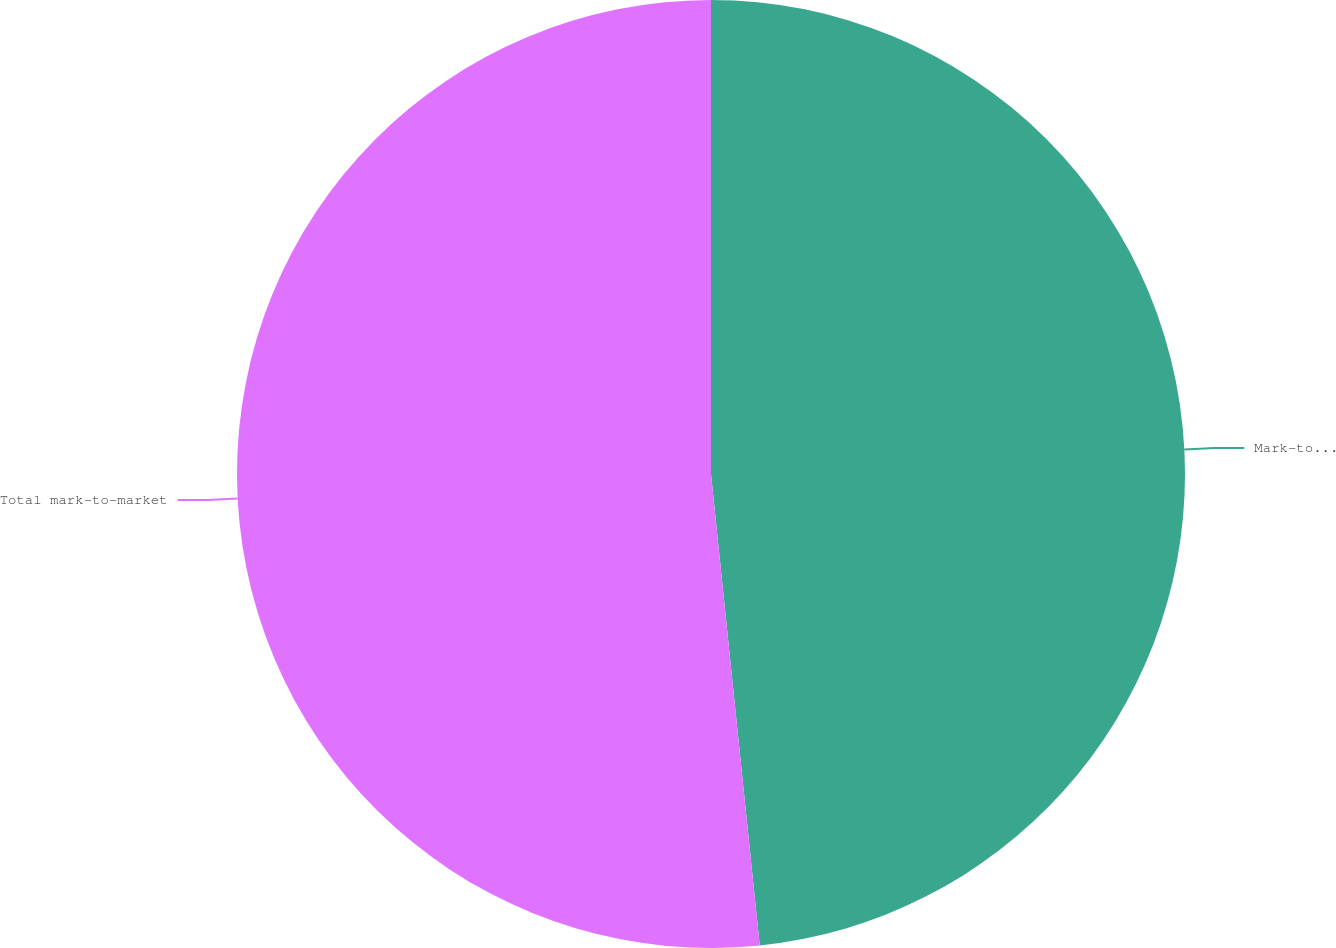Convert chart. <chart><loc_0><loc_0><loc_500><loc_500><pie_chart><fcel>Mark-to-market derivative<fcel>Total mark-to-market<nl><fcel>48.36%<fcel>51.64%<nl></chart> 